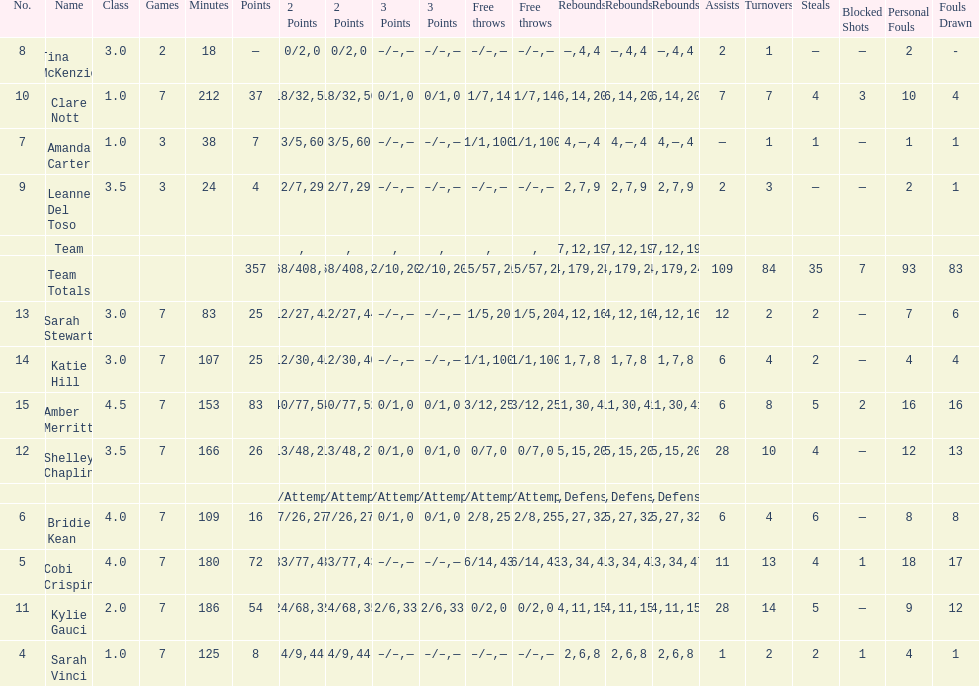Total number of assists and turnovers combined 193. 